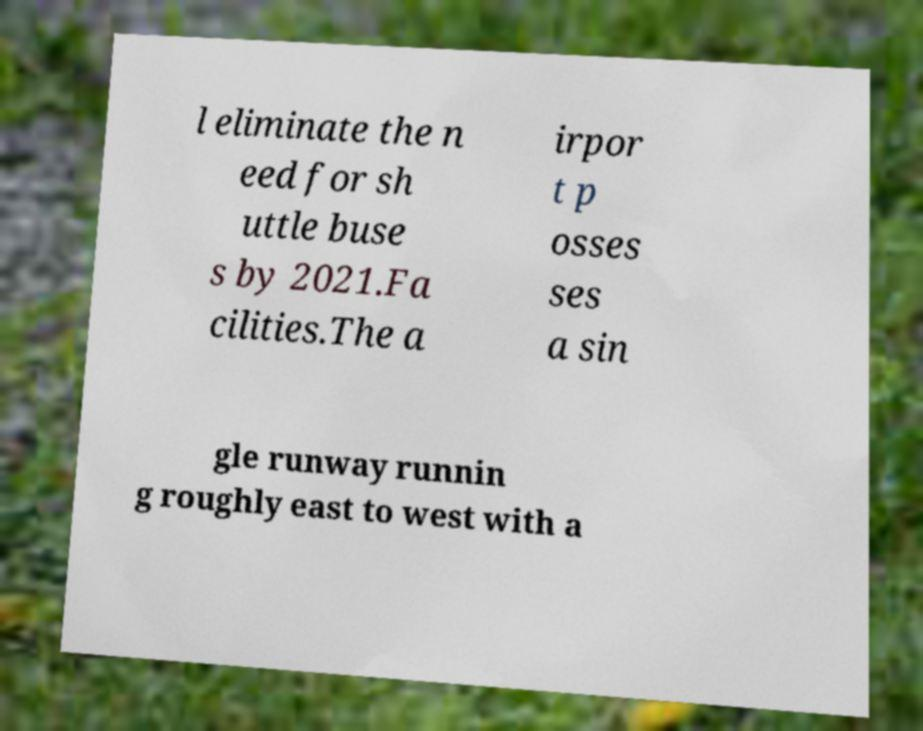Could you extract and type out the text from this image? l eliminate the n eed for sh uttle buse s by 2021.Fa cilities.The a irpor t p osses ses a sin gle runway runnin g roughly east to west with a 